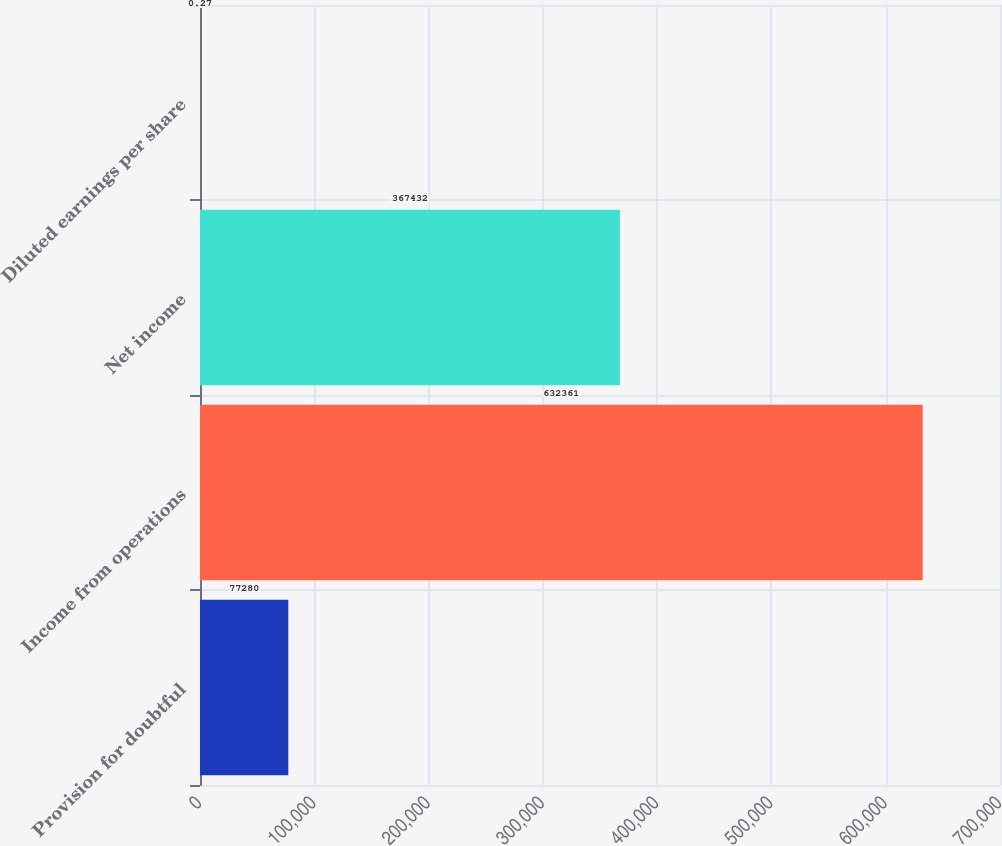Convert chart to OTSL. <chart><loc_0><loc_0><loc_500><loc_500><bar_chart><fcel>Provision for doubtful<fcel>Income from operations<fcel>Net income<fcel>Diluted earnings per share<nl><fcel>77280<fcel>632361<fcel>367432<fcel>0.27<nl></chart> 